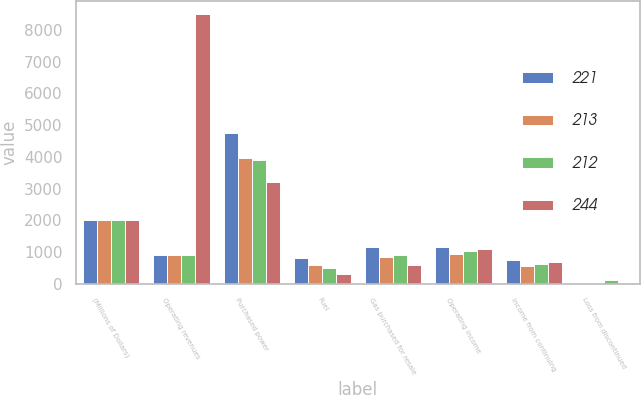Convert chart to OTSL. <chart><loc_0><loc_0><loc_500><loc_500><stacked_bar_chart><ecel><fcel>(Millions of Dollars)<fcel>Operating revenues<fcel>Purchased power<fcel>Fuel<fcel>Gas purchased for resale<fcel>Operating income<fcel>Income from continuing<fcel>Loss from discontinued<nl><fcel>221<fcel>2005<fcel>889<fcel>4743<fcel>816<fcel>1155<fcel>1158<fcel>732<fcel>13<nl><fcel>213<fcel>2004<fcel>889<fcel>3960<fcel>597<fcel>852<fcel>931<fcel>549<fcel>12<nl><fcel>212<fcel>2003<fcel>889<fcel>3884<fcel>504<fcel>889<fcel>1044<fcel>634<fcel>109<nl><fcel>244<fcel>2002<fcel>8498<fcel>3201<fcel>289<fcel>596<fcel>1078<fcel>689<fcel>21<nl></chart> 